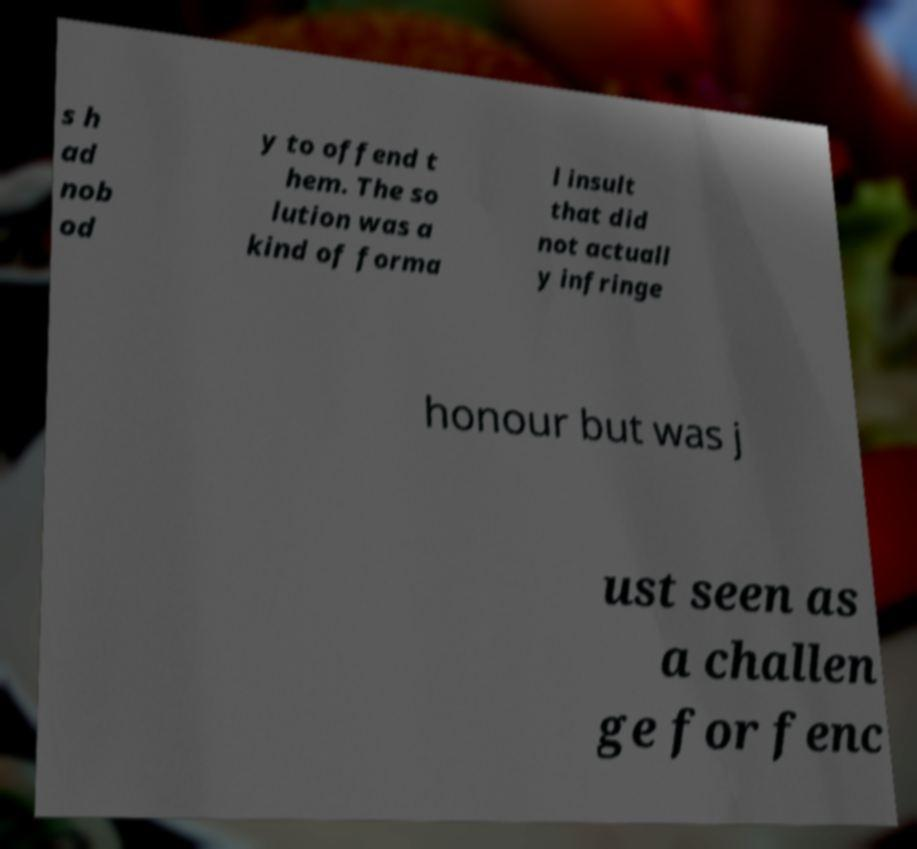Could you extract and type out the text from this image? s h ad nob od y to offend t hem. The so lution was a kind of forma l insult that did not actuall y infringe honour but was j ust seen as a challen ge for fenc 